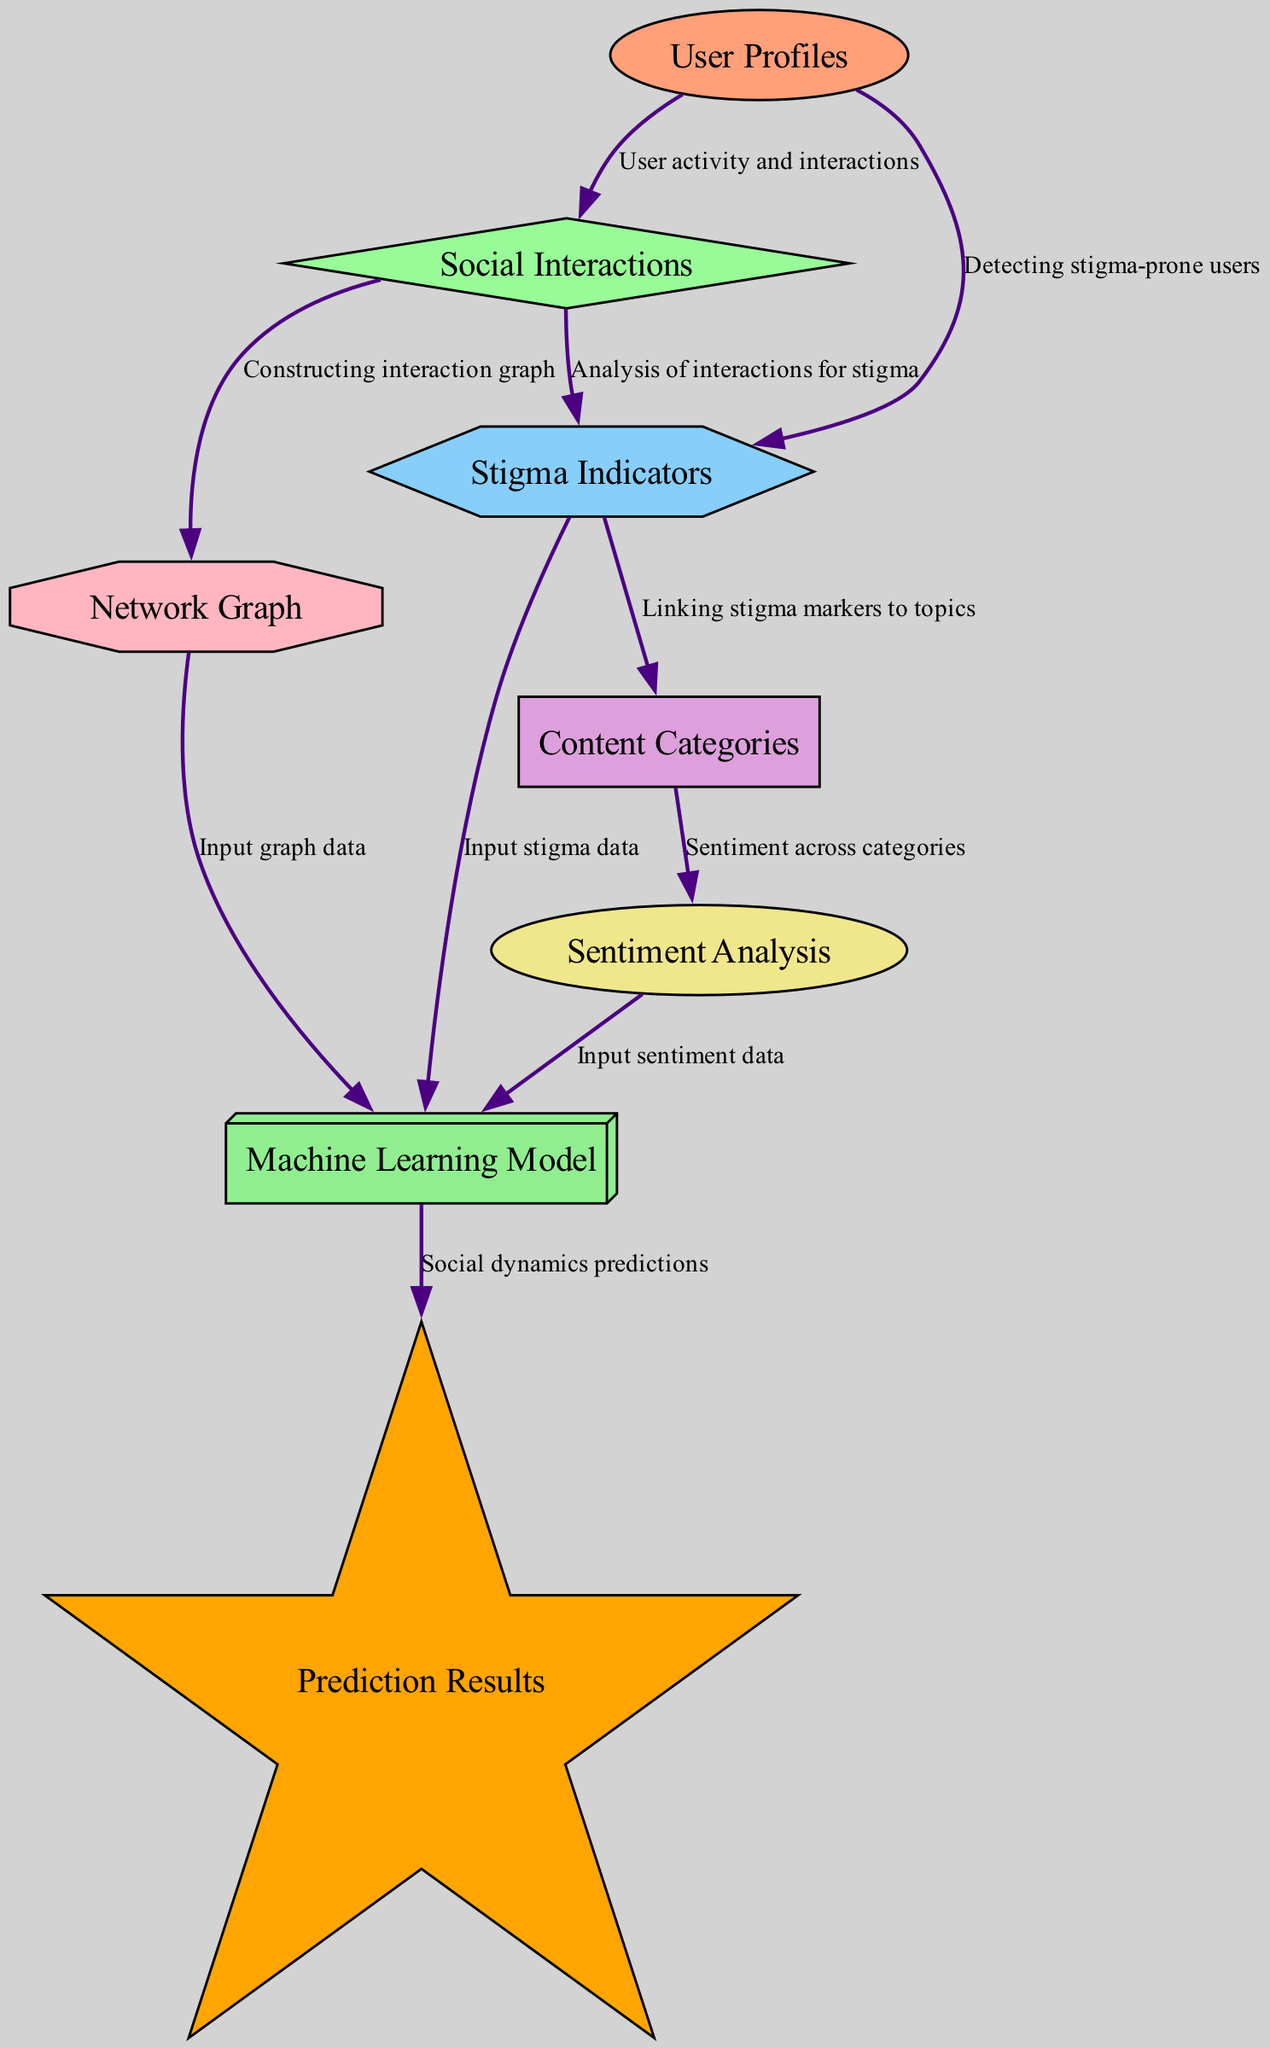What is the label of the node connected to User Profiles with an edge labeled "User activity and interactions"? The node labeled "Social Interactions" is directly connected to "User Profiles" by that edge.
Answer: Social Interactions How many nodes are there in the diagram? By counting each unique node listed in the diagram, we find there are a total of 8 nodes.
Answer: 8 Which node receives input data from both Sentiment Analysis and Stigma Indicators? The node labeled "ML Model" receives input data from both specified nodes, indicating it combines sentiment and stigma data for predictions.
Answer: ML Model What is the relationship between Stigma Indicators and Content Categories? The edge labeled "Linking stigma markers to topics" indicates that Stigma Indicators are associated with Content Categories, showing how stigma features relate to discussion topics.
Answer: Linking stigma markers to topics What is the final output of the ML Model? The output of the ML Model is specified as "Prediction Results," which represents the result of the social dynamics predictions made by the model.
Answer: Prediction Results Which node describes the features indicating stigmatization in user-generated content? The node labeled "Stigma Indicators" specifically describes the features related to stigma in content produced by users, highlighting its focus on stigma measurement.
Answer: Stigma Indicators How is the Network Graph created in relation to Social Interactions? The "Network Graph" node is constructed from the "Social Interactions" data, as indicated by the edge labeled "Constructing interaction graph.”
Answer: Constructing interaction graph What type of analysis is performed on Content Categories? "Sentiment Analysis" is performed on "Content Categories," as suggested by the edge labeled "Sentiment across categories," which connects the two nodes.
Answer: Sentiment across categories 